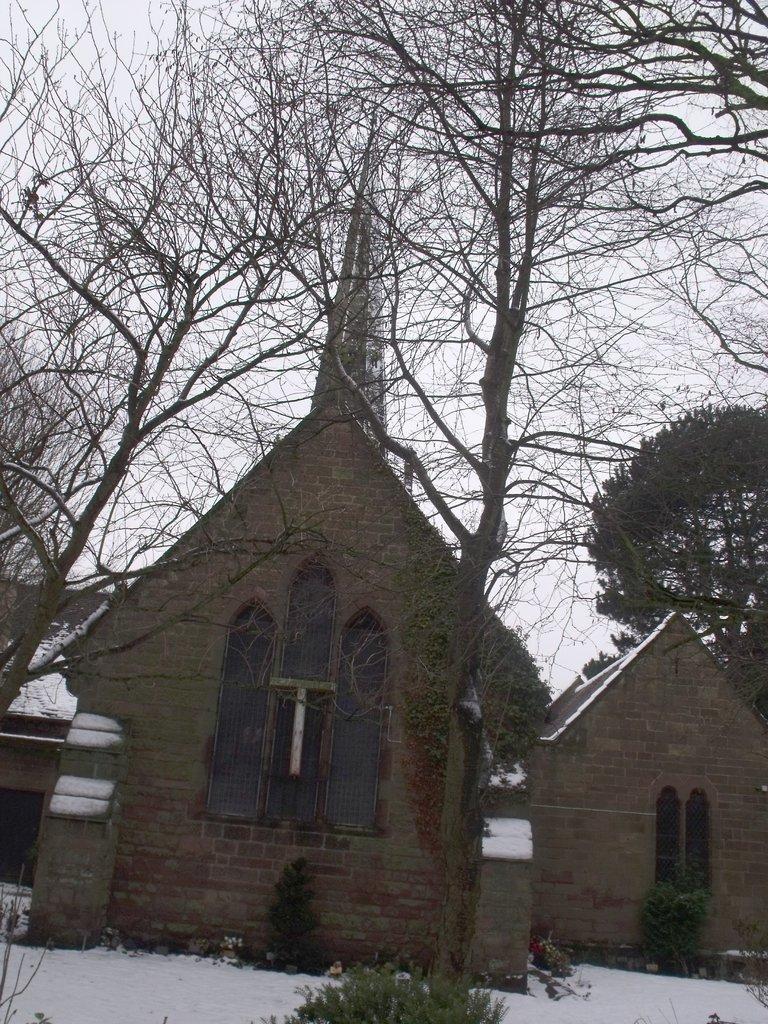Describe this image in one or two sentences. In this image we can see there are houses and snow. And there are trees and the sky. 